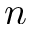<formula> <loc_0><loc_0><loc_500><loc_500>n</formula> 